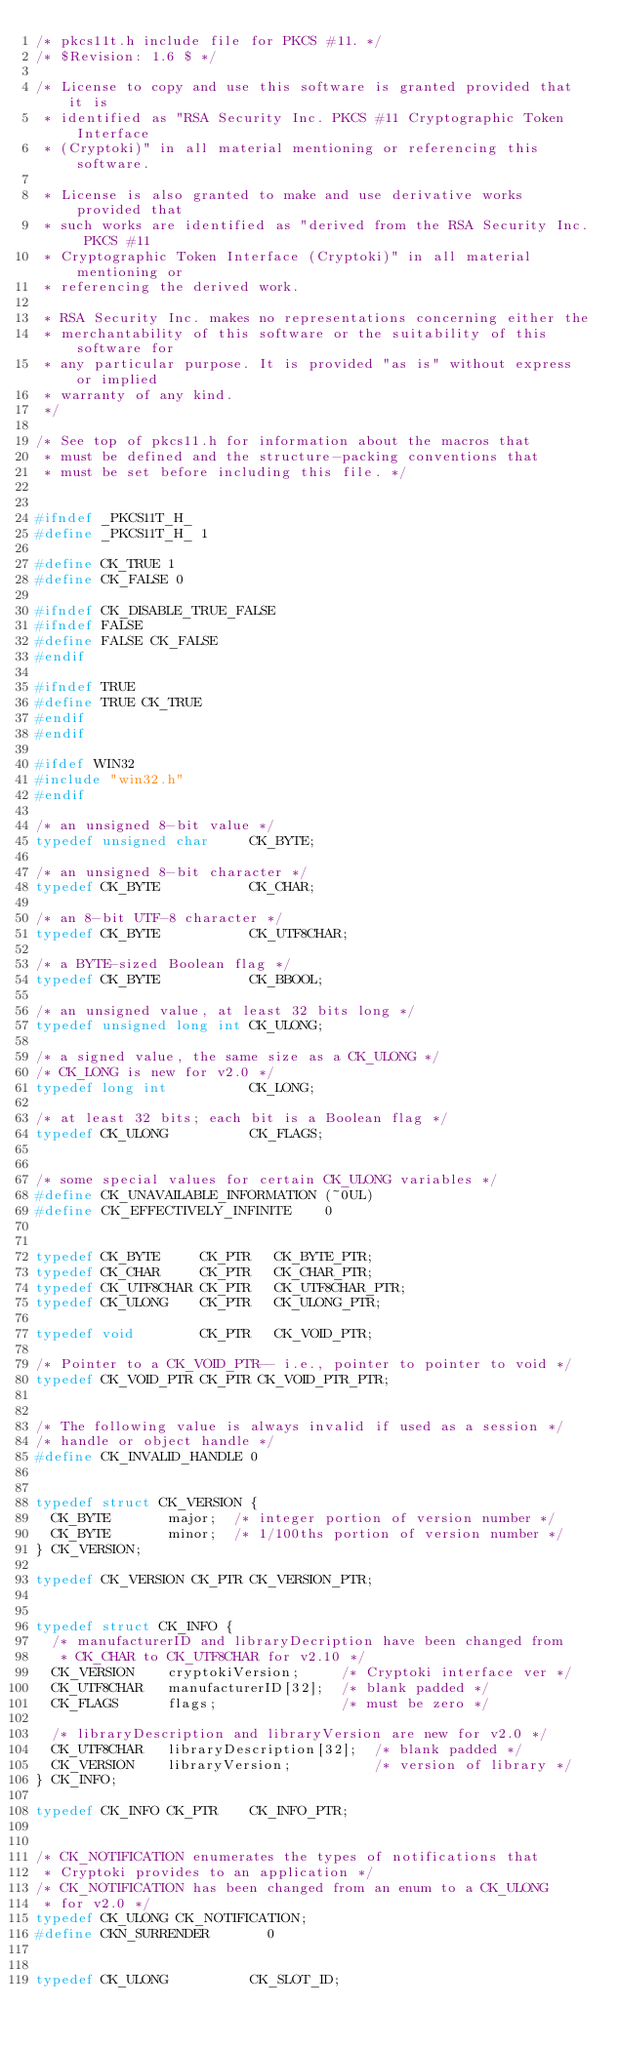Convert code to text. <code><loc_0><loc_0><loc_500><loc_500><_C_>/* pkcs11t.h include file for PKCS #11. */
/* $Revision: 1.6 $ */

/* License to copy and use this software is granted provided that it is
 * identified as "RSA Security Inc. PKCS #11 Cryptographic Token Interface
 * (Cryptoki)" in all material mentioning or referencing this software.

 * License is also granted to make and use derivative works provided that
 * such works are identified as "derived from the RSA Security Inc. PKCS #11
 * Cryptographic Token Interface (Cryptoki)" in all material mentioning or
 * referencing the derived work.

 * RSA Security Inc. makes no representations concerning either the
 * merchantability of this software or the suitability of this software for
 * any particular purpose. It is provided "as is" without express or implied
 * warranty of any kind.
 */

/* See top of pkcs11.h for information about the macros that
 * must be defined and the structure-packing conventions that
 * must be set before including this file. */


#ifndef _PKCS11T_H_
#define _PKCS11T_H_ 1

#define CK_TRUE 1
#define CK_FALSE 0

#ifndef CK_DISABLE_TRUE_FALSE
#ifndef FALSE
#define FALSE CK_FALSE
#endif

#ifndef TRUE
#define TRUE CK_TRUE
#endif
#endif

#ifdef WIN32
#include "win32.h"
#endif

/* an unsigned 8-bit value */
typedef unsigned char     CK_BYTE;

/* an unsigned 8-bit character */
typedef CK_BYTE           CK_CHAR;

/* an 8-bit UTF-8 character */
typedef CK_BYTE           CK_UTF8CHAR;

/* a BYTE-sized Boolean flag */
typedef CK_BYTE           CK_BBOOL;

/* an unsigned value, at least 32 bits long */
typedef unsigned long int CK_ULONG;

/* a signed value, the same size as a CK_ULONG */
/* CK_LONG is new for v2.0 */
typedef long int          CK_LONG;

/* at least 32 bits; each bit is a Boolean flag */
typedef CK_ULONG          CK_FLAGS;


/* some special values for certain CK_ULONG variables */
#define CK_UNAVAILABLE_INFORMATION (~0UL)
#define CK_EFFECTIVELY_INFINITE    0

 
typedef CK_BYTE     CK_PTR   CK_BYTE_PTR;
typedef CK_CHAR     CK_PTR   CK_CHAR_PTR;
typedef CK_UTF8CHAR CK_PTR   CK_UTF8CHAR_PTR;
typedef CK_ULONG    CK_PTR   CK_ULONG_PTR;

typedef void        CK_PTR   CK_VOID_PTR;

/* Pointer to a CK_VOID_PTR-- i.e., pointer to pointer to void */
typedef CK_VOID_PTR CK_PTR CK_VOID_PTR_PTR;


/* The following value is always invalid if used as a session */
/* handle or object handle */
#define CK_INVALID_HANDLE 0


typedef struct CK_VERSION {
  CK_BYTE       major;  /* integer portion of version number */
  CK_BYTE       minor;  /* 1/100ths portion of version number */
} CK_VERSION;

typedef CK_VERSION CK_PTR CK_VERSION_PTR;


typedef struct CK_INFO {
  /* manufacturerID and libraryDecription have been changed from
   * CK_CHAR to CK_UTF8CHAR for v2.10 */
  CK_VERSION    cryptokiVersion;     /* Cryptoki interface ver */
  CK_UTF8CHAR   manufacturerID[32];  /* blank padded */
  CK_FLAGS      flags;               /* must be zero */

  /* libraryDescription and libraryVersion are new for v2.0 */
  CK_UTF8CHAR   libraryDescription[32];  /* blank padded */
  CK_VERSION    libraryVersion;          /* version of library */
} CK_INFO;

typedef CK_INFO CK_PTR    CK_INFO_PTR;


/* CK_NOTIFICATION enumerates the types of notifications that
 * Cryptoki provides to an application */
/* CK_NOTIFICATION has been changed from an enum to a CK_ULONG
 * for v2.0 */
typedef CK_ULONG CK_NOTIFICATION;
#define CKN_SURRENDER       0


typedef CK_ULONG          CK_SLOT_ID;
</code> 